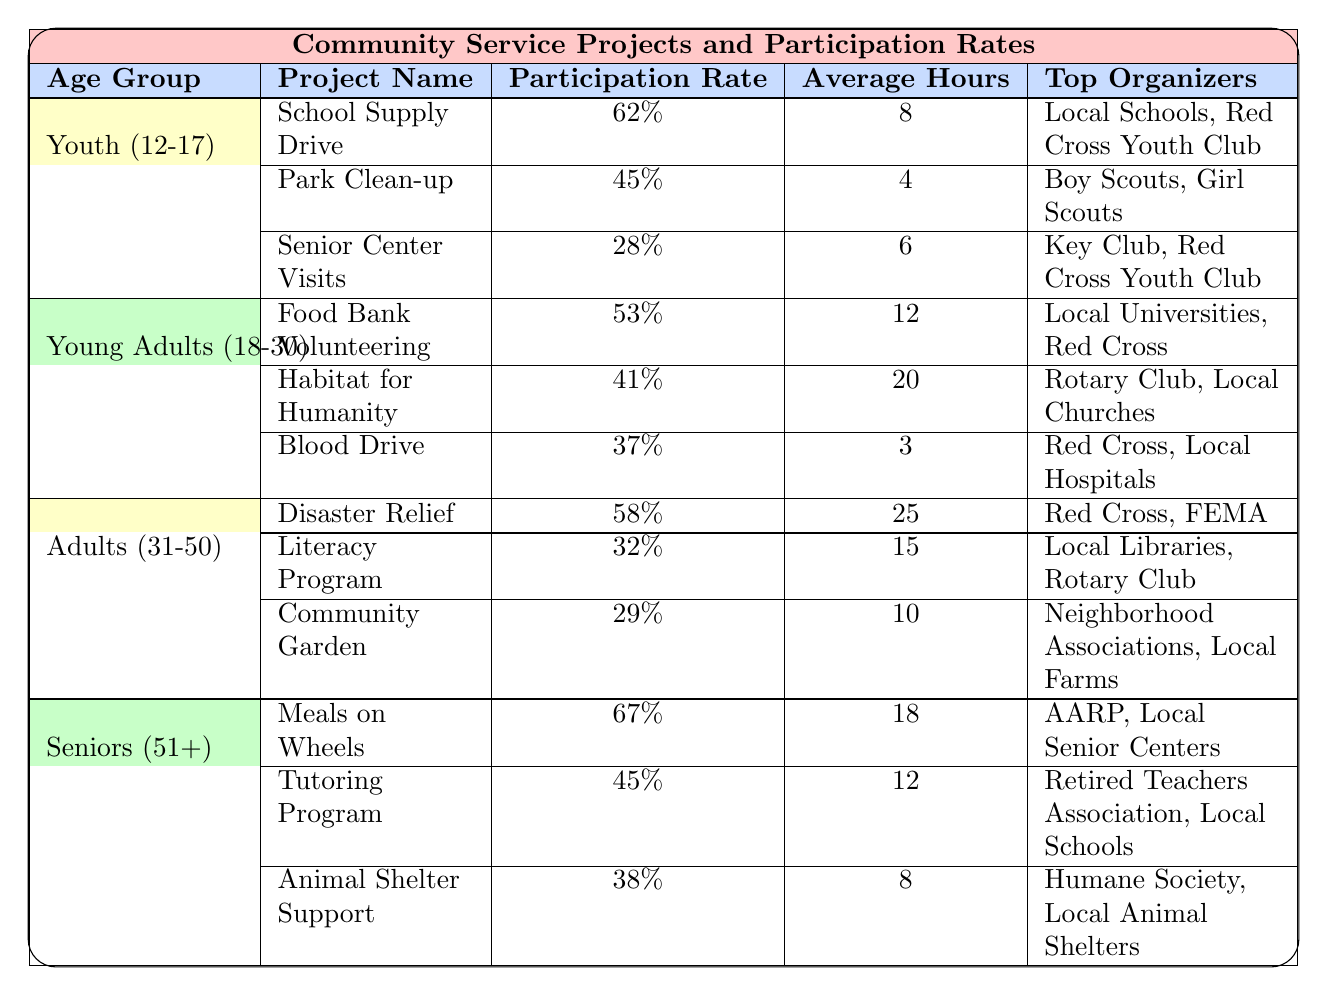What is the participation rate for the "Meals on Wheels" project? The "Meals on Wheels" project is listed under the Seniors (51+) age group in the table. Its participation rate is shown as 67%.
Answer: 67% Which age group has the highest participation rate for community service projects? Looking at the participation rates in the table across all age groups, the Seniors (51+) group has the highest rate for "Meals on Wheels" at 67%, compared to the others.
Answer: Seniors (51+) What is the average number of hours spent on volunteering for the "Disaster Relief" project by Adults (31-50)? The "Disaster Relief" project under the Adults (31-50) age group shows an average of 25 hours spent on volunteering.
Answer: 25 hours Is the participation rate for the "Blood Drive" project higher than 40%? The "Blood Drive" project under the Young Adults (18-30) age group has a participation rate of 37%, which is less than 40%.
Answer: No What is the difference in participation rates between the "Food Bank Volunteering" and "Park Clean-up" projects? The participation rate for the "Food Bank Volunteering" project is 53% (Young Adults 18-30) and for the "Park Clean-up" project is 45% (Youth 12-17). The difference is 53% - 45% = 8%.
Answer: 8% How many projects have a participation rate above 60% in the table? In the table, the projects with participation rates above 60% are "Meals on Wheels" (67%) and "School Supply Drive" (62%). That totals to two projects.
Answer: 2 What age group has the lowest average hours spent on community service projects? By calculating the average hours for each age group: Youth (12-17): (8 + 4 + 6)/3 = 6; Young Adults (18-30): (12 + 20 + 3)/3 = 11.67; Adults (31-50): (25 + 15 + 10)/3 = 16.67; Seniors (51+): (18 + 12 + 8)/3 = 12.67. The Youth (12-17) group has the lowest average at 6 hours.
Answer: Youth (12-17) Can you identify which project has the lowest participation rate across all age groups? The project with the lowest participation rate listed in all age groups is "Senior Center Visits" with a rate of 28% in the Youth (12-17) category.
Answer: Senior Center Visits What project among the Young Adults (18-30) group requires the most average hours for volunteering? The "Habitat for Humanity" project requires an average of 20 hours for volunteering, which is more than the other projects (Food Bank Volunteering and Blood Drive).
Answer: Habitat for Humanity Do all projects under the Seniors (51+) age group have participation rates above 35%? The participation rates for the Seniors (51+) age group are "Meals on Wheels" (67%), "Tutoring Program" (45%), and "Animal Shelter Support" (38%). Since all are above 35%, the answer is yes.
Answer: Yes 